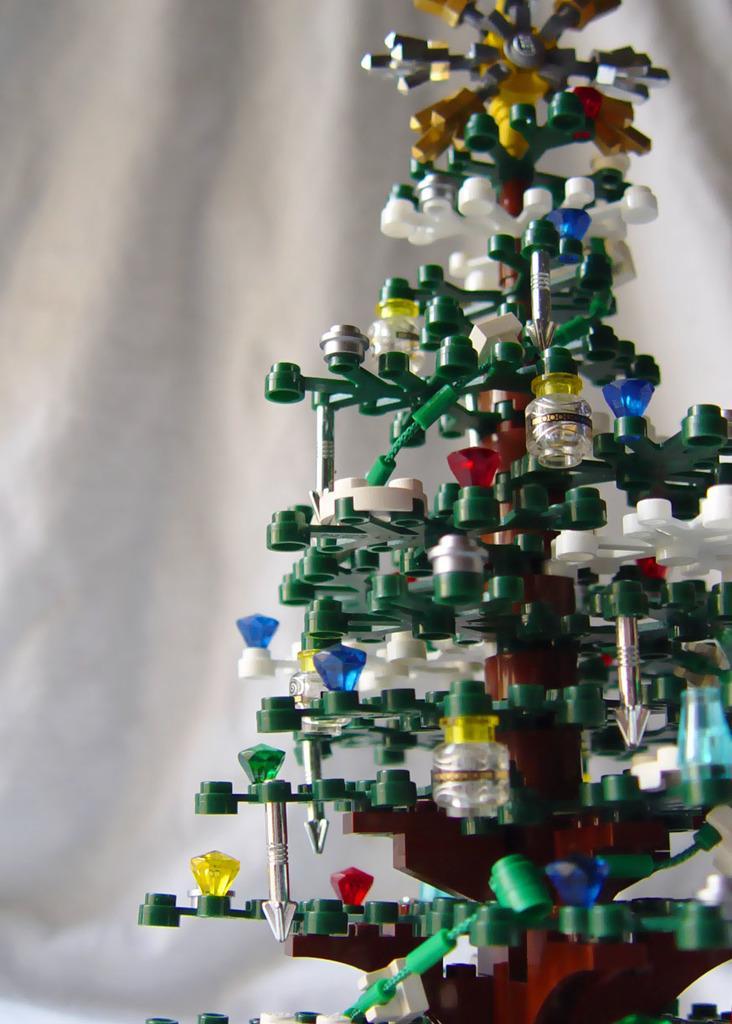Could you give a brief overview of what you see in this image? In this picture we can see a decorative Christmas tree. Background it is white. 